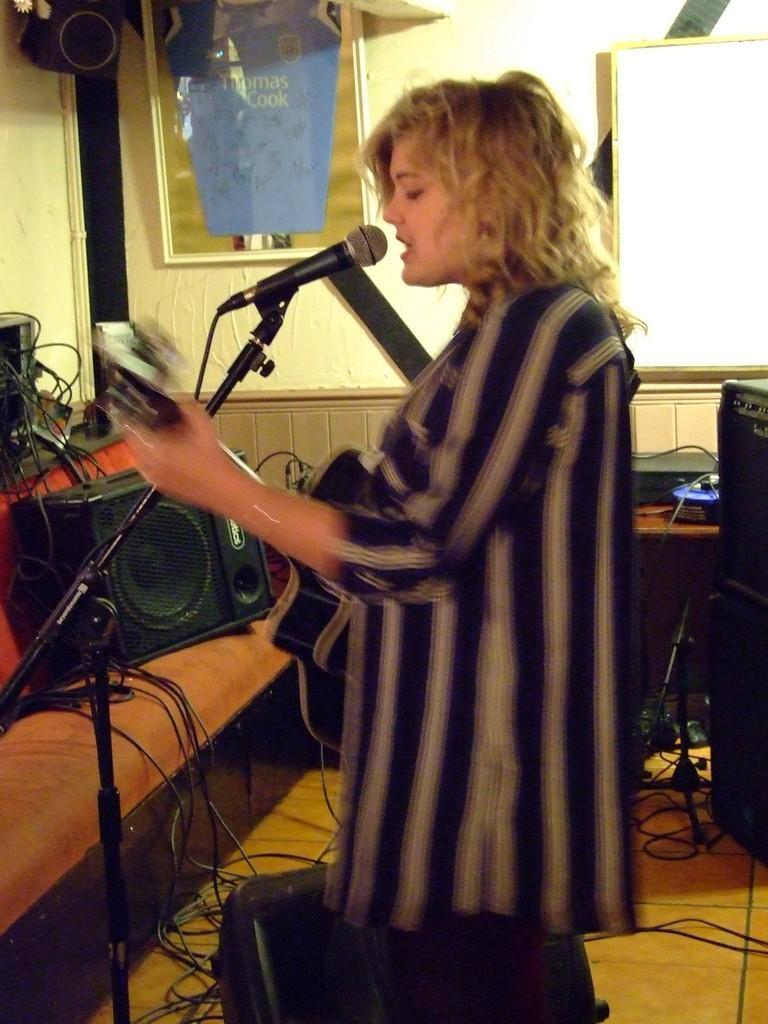Please provide a concise description of this image. This picture is taken in a room. There is a woman, she is holding something and singing on a mike. In the background there are some sound speakers, wires and a wall. 